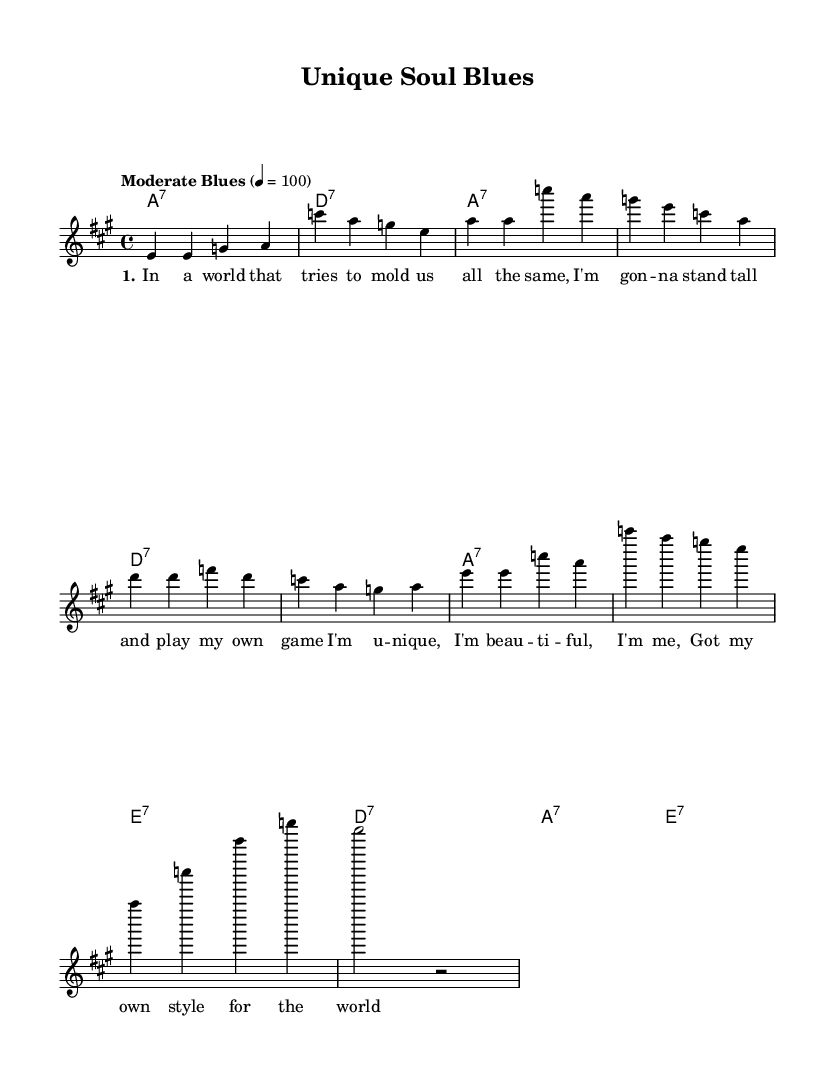What is the key signature of this music? The key signature is A major, which has three sharps (F#, C#, and G#). This can be determined by looking at the `\key a \major` directive in the global section of the LilyPond code.
Answer: A major What is the time signature of this music? The time signature is 4/4, indicating four beats in each measure and a quarter note representing one beat. This can be identified from the `\time 4/4` directive in the global section of the code.
Answer: 4/4 What is the tempo marking for the music? The tempo marking is "Moderate Blues," which sets the pace at 100 beats per minute as indicated by the `\tempo "Moderate Blues" 4 = 100`.
Answer: Moderate Blues How many measures are there in the melody? There are 8 measures in the melody. This can be counted by observing the number of groups separated by the bar lines in the melody section.
Answer: 8 What is the predominant chord used throughout the piece? The predominant chord used throughout the piece is A7. This can be identified as it appears most frequently in the harmonies section, specifically it is used in measures 1 to 4.
Answer: A7 What is the lyrical theme of the first verse? The lyrical theme of the first verse revolves around individuality and self-acceptance, as expressed through lines such as “I'm gon -- na stand tall and play my own game.” This reflects the content of the lyrics in the verse.
Answer: Individuality Which section contains the chorus? The chorus is contained in the section labeled “chorus” after the verse in the LilyPond code. This section lays out the empowering message of being unique and beautiful.
Answer: Chorus 